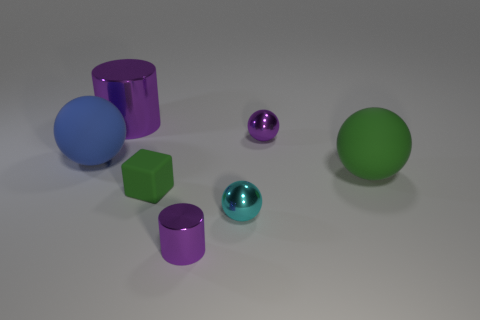Add 1 blue matte spheres. How many objects exist? 8 Subtract all balls. How many objects are left? 3 Add 3 tiny balls. How many tiny balls are left? 5 Add 6 yellow shiny cubes. How many yellow shiny cubes exist? 6 Subtract 0 gray spheres. How many objects are left? 7 Subtract all green balls. Subtract all small blocks. How many objects are left? 5 